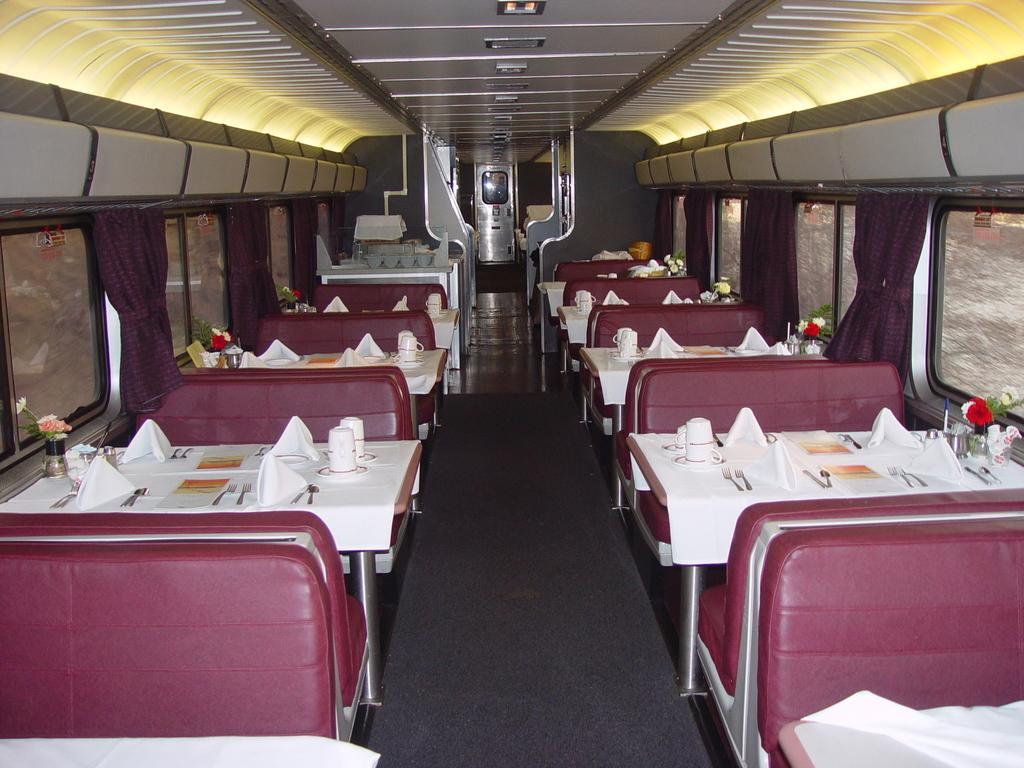What type of furniture is present in the image? There are dining tables in the image. What can be used to sit on near the dining tables? There are seats associated with the dining tables. What utensils are visible in the image? There are forks and knives in the image. What might be used for cleaning or wiping in the image? There are tissue papers in the image. How does the shoe change the temper of the person in the image? There is no shoe or person present in the image, so it is not possible to determine any effect on temper. 